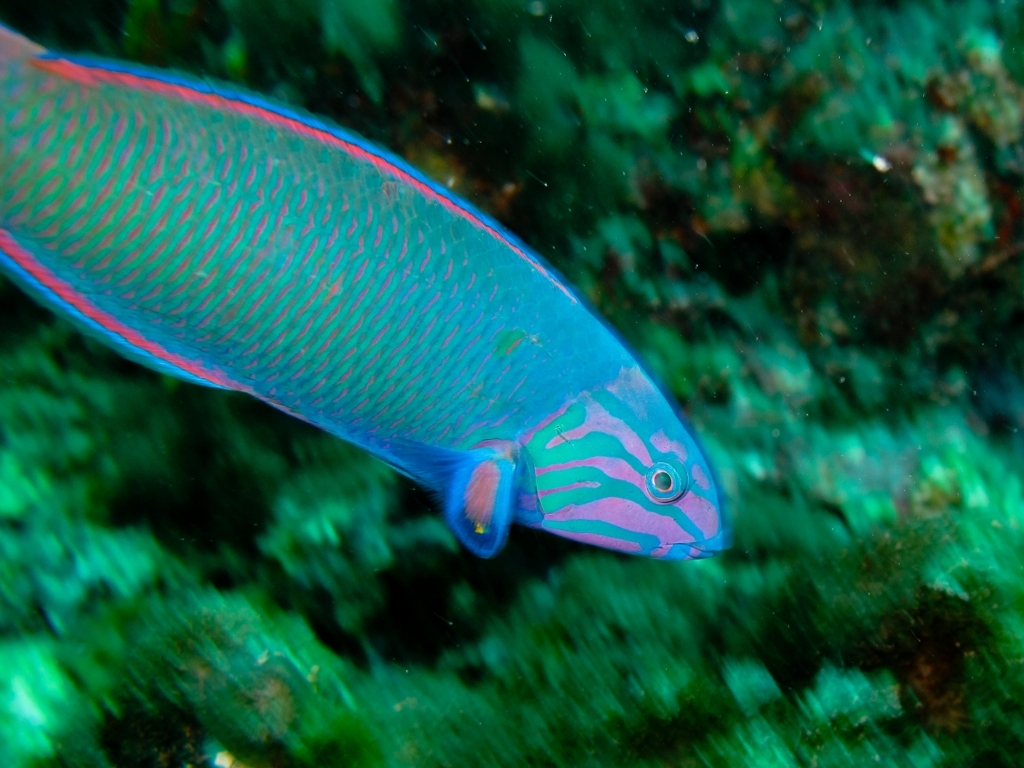What are the adaptations that make this fish suitable for its environment? The Parrotfish's adaptations include its vibrant coloration, which can serve as camouflage among the colorful coral. Its beak-like mouth allows it to scrape algae from coral and rocks, and its pharyngeal teeth help it to grind up coral pieces it ingests, which is later excreted as sand, contributing to the sandy floor of its habitat. 